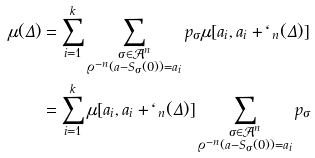Convert formula to latex. <formula><loc_0><loc_0><loc_500><loc_500>\mu ( \Delta ) & = \sum _ { i = 1 } ^ { k } \sum _ { \substack { \sigma \in \mathcal { A } ^ { n } \\ \varrho ^ { - n } ( a - S _ { \sigma } ( 0 ) ) = a _ { i } } } p _ { \sigma } \mu [ a _ { i } , a _ { i } + \ell _ { n } ( \Delta ) ] \\ & = \sum _ { i = 1 } ^ { k } \mu [ a _ { i } , a _ { i } + \ell _ { n } ( \Delta ) ] \sum _ { \substack { \sigma \in \mathcal { A } ^ { n } \\ \varrho ^ { - n } ( a - S _ { \sigma } ( 0 ) ) = a _ { i } } } p _ { \sigma }</formula> 